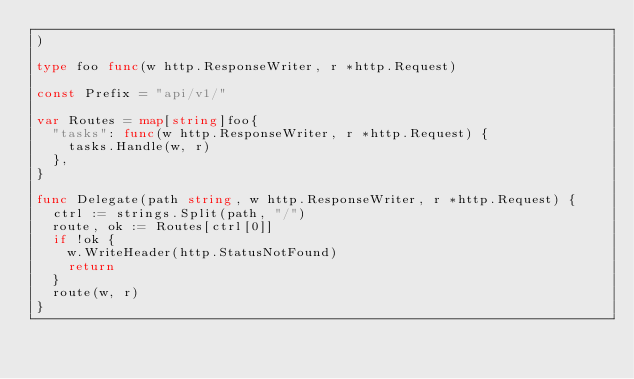Convert code to text. <code><loc_0><loc_0><loc_500><loc_500><_Go_>)

type foo func(w http.ResponseWriter, r *http.Request)

const Prefix = "api/v1/"

var Routes = map[string]foo{
	"tasks": func(w http.ResponseWriter, r *http.Request) {
		tasks.Handle(w, r)
	},
}

func Delegate(path string, w http.ResponseWriter, r *http.Request) {
	ctrl := strings.Split(path, "/")
	route, ok := Routes[ctrl[0]]
	if !ok {
		w.WriteHeader(http.StatusNotFound)
		return
	}
	route(w, r)
}
</code> 